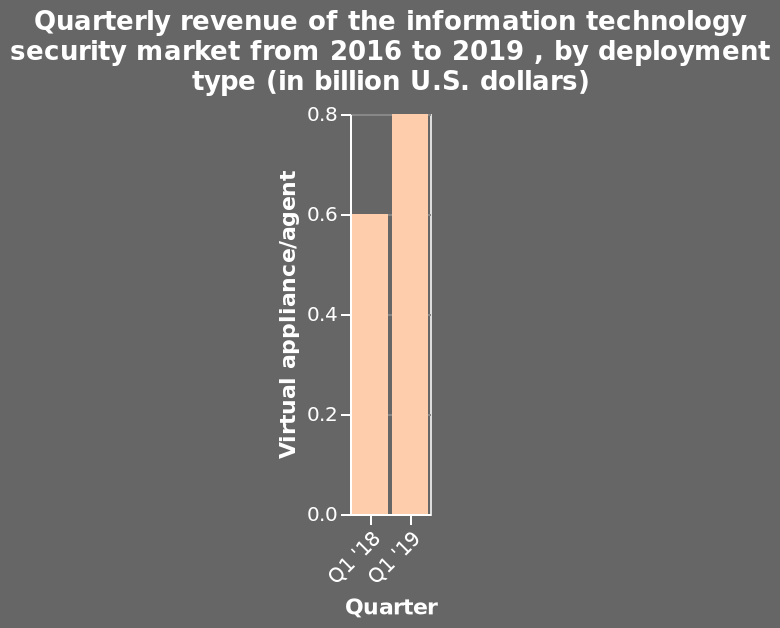<image>
Offer a thorough analysis of the image. The quarterly revenue of virtual appliance/agents within the info sec market has increased by 0.2 billion dollars from 2018 to 2019, which represents a 33% increase. please enumerates aspects of the construction of the chart This is a bar plot titled Quarterly revenue of the information technology security market from 2016 to 2019 , by deployment type (in billion U.S. dollars). Along the x-axis, Quarter is measured using a categorical scale starting at Q1 '18 and ending at Q1 '19. Virtual appliance/agent is plotted using a linear scale of range 0.0 to 0.8 along the y-axis. What is the range of the y-axis on the bar plot? The range of the y-axis on the bar plot is from 0.0 to 0.8. 